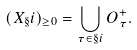Convert formula to latex. <formula><loc_0><loc_0><loc_500><loc_500>( X _ { \S } i ) _ { \geq 0 } = \bigcup _ { \tau \in \S i } O _ { \tau } ^ { + } .</formula> 